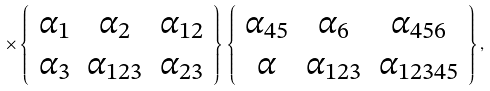Convert formula to latex. <formula><loc_0><loc_0><loc_500><loc_500>\times \left \{ \begin{array} { c c c } \alpha _ { 1 } & \alpha _ { 2 } & \alpha _ { 1 2 } \\ \alpha _ { 3 } & \alpha _ { 1 2 3 } & \alpha _ { 2 3 } \end{array} \right \} \left \{ \begin{array} { c c c } \alpha _ { 4 5 } & \alpha _ { 6 } & \alpha _ { 4 5 6 } \\ \alpha & \alpha _ { 1 2 3 } & \alpha _ { 1 2 3 4 5 } \end{array} \right \} ,</formula> 